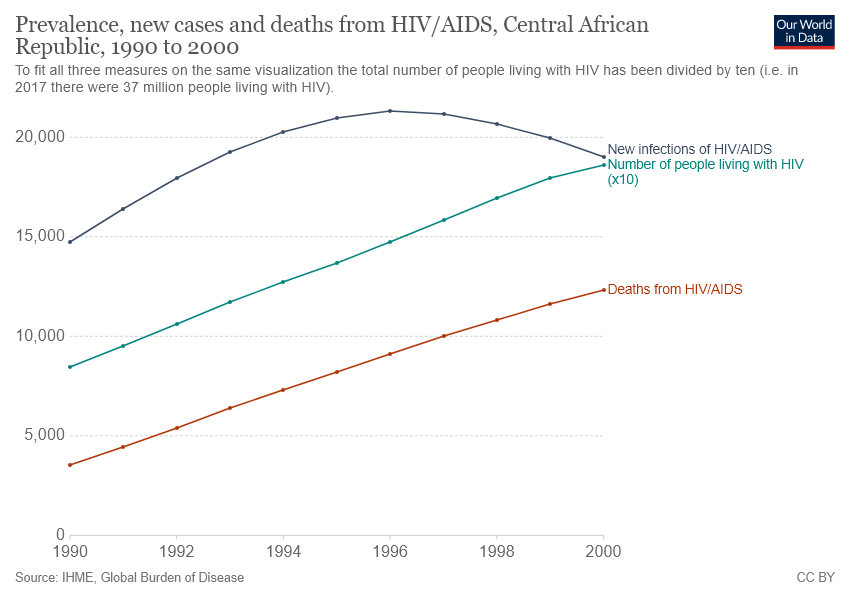Highlight a few significant elements in this photo. The chart shows a decrease in the experience of data related to new infections of HIV/AIDS. The color of the line representing deaths is red. 